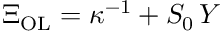Convert formula to latex. <formula><loc_0><loc_0><loc_500><loc_500>\Xi _ { O L } = \kappa ^ { - 1 } + S _ { 0 } \, Y</formula> 